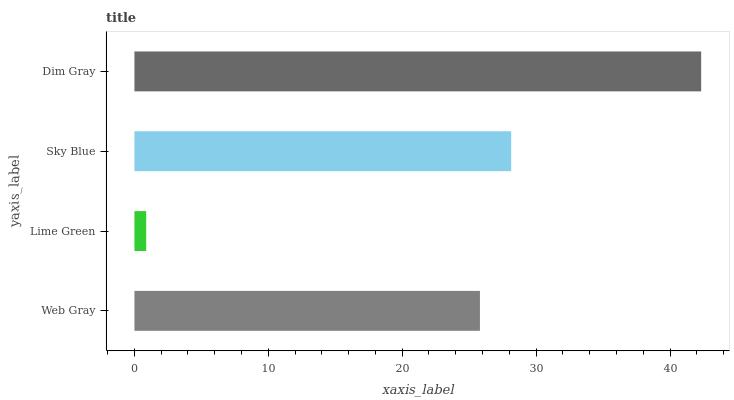Is Lime Green the minimum?
Answer yes or no. Yes. Is Dim Gray the maximum?
Answer yes or no. Yes. Is Sky Blue the minimum?
Answer yes or no. No. Is Sky Blue the maximum?
Answer yes or no. No. Is Sky Blue greater than Lime Green?
Answer yes or no. Yes. Is Lime Green less than Sky Blue?
Answer yes or no. Yes. Is Lime Green greater than Sky Blue?
Answer yes or no. No. Is Sky Blue less than Lime Green?
Answer yes or no. No. Is Sky Blue the high median?
Answer yes or no. Yes. Is Web Gray the low median?
Answer yes or no. Yes. Is Web Gray the high median?
Answer yes or no. No. Is Sky Blue the low median?
Answer yes or no. No. 